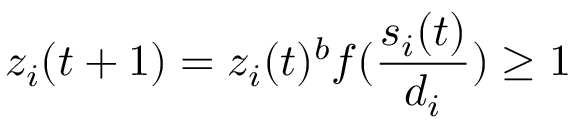<formula> <loc_0><loc_0><loc_500><loc_500>z _ { i } ( t + 1 ) = z _ { i } ( t ) ^ { b } f ( \frac { s _ { i } ( t ) } { d _ { i } } ) \geq 1</formula> 